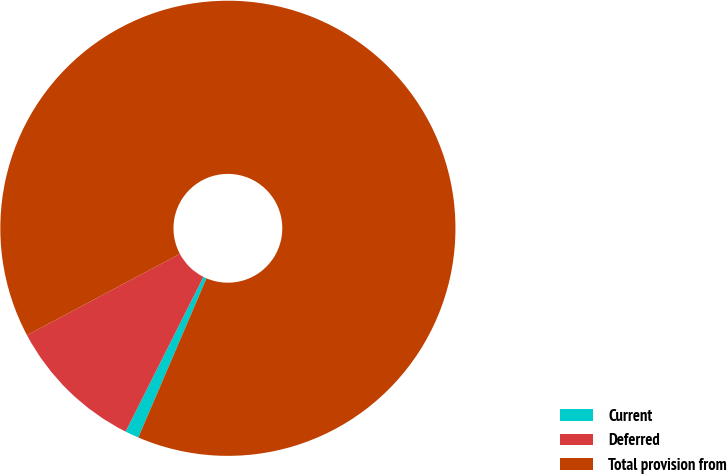Convert chart to OTSL. <chart><loc_0><loc_0><loc_500><loc_500><pie_chart><fcel>Current<fcel>Deferred<fcel>Total provision from<nl><fcel>0.98%<fcel>9.8%<fcel>89.22%<nl></chart> 